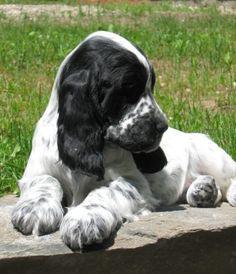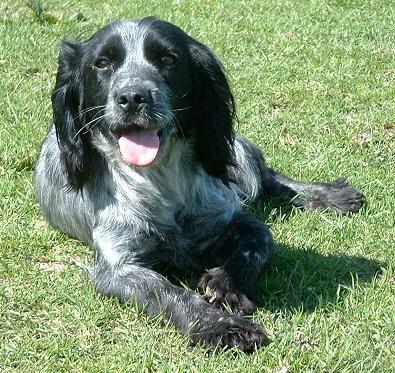The first image is the image on the left, the second image is the image on the right. For the images shown, is this caption "The dog in the image on the right is carrying something in it's mouth." true? Answer yes or no. No. The first image is the image on the left, the second image is the image on the right. Given the left and right images, does the statement "One of the dogs is carrying something in its mouth." hold true? Answer yes or no. No. 